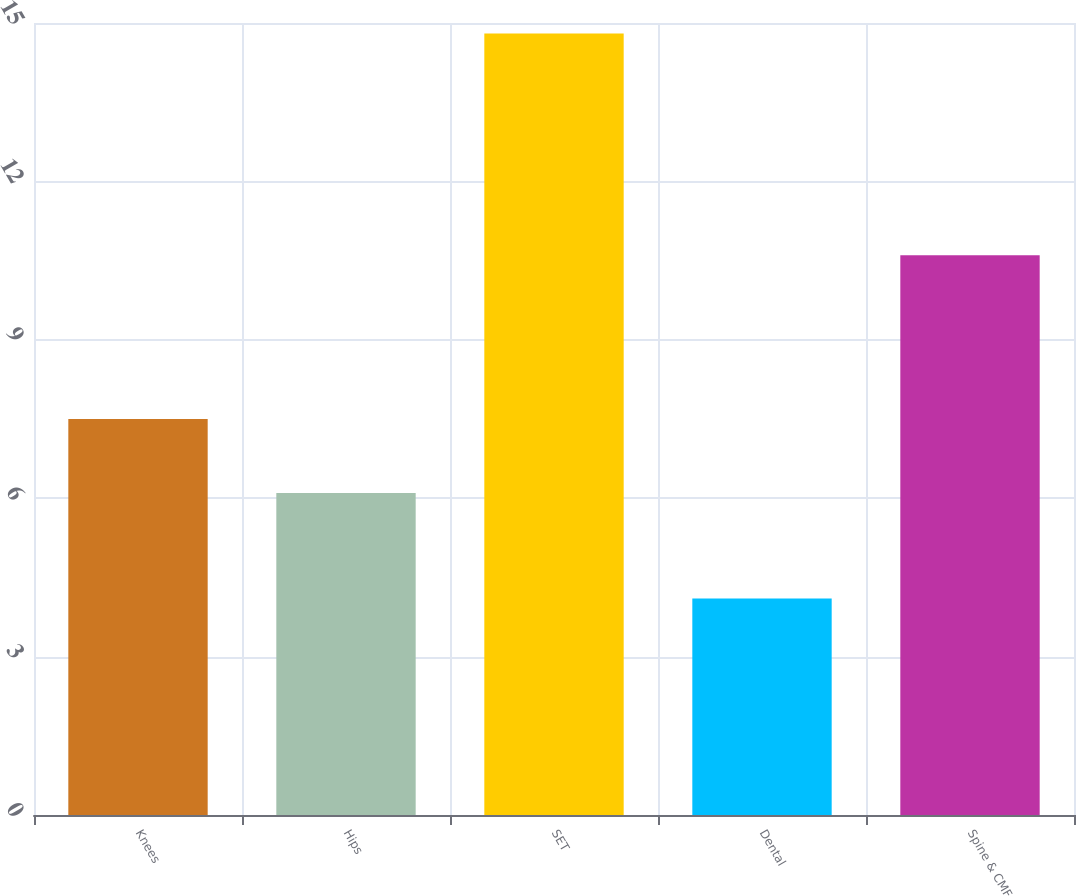Convert chart. <chart><loc_0><loc_0><loc_500><loc_500><bar_chart><fcel>Knees<fcel>Hips<fcel>SET<fcel>Dental<fcel>Spine & CMF<nl><fcel>7.5<fcel>6.1<fcel>14.8<fcel>4.1<fcel>10.6<nl></chart> 